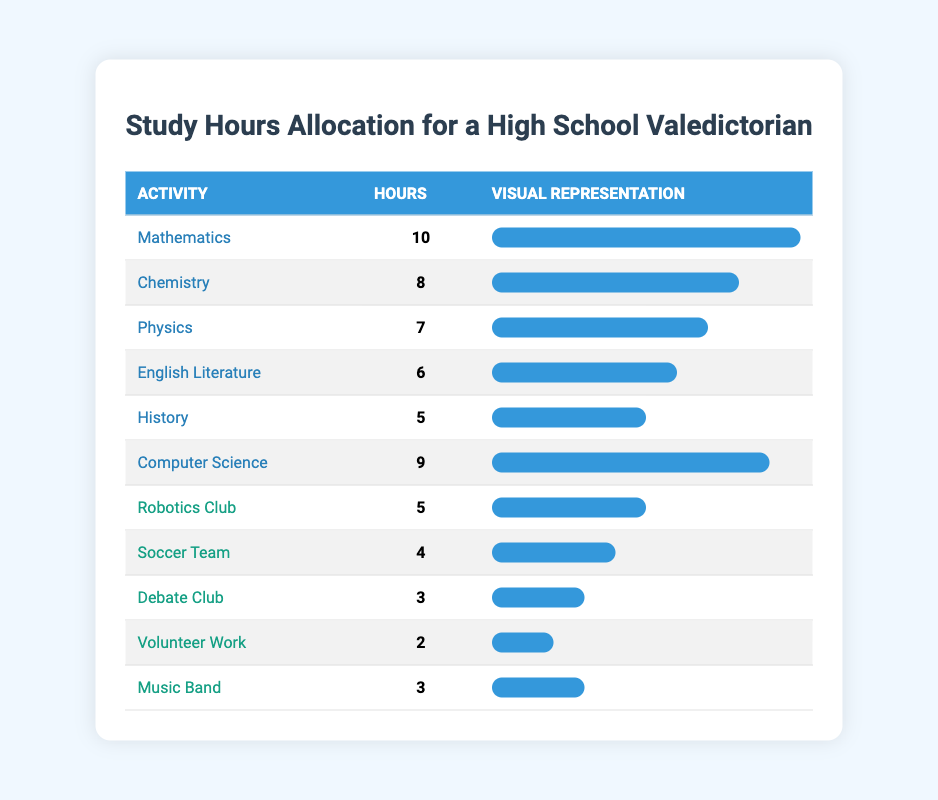What subject receives the most study hours? By examining the table, we can see that Mathematics has the highest number of study hours allocated, which is 10 hours.
Answer: Mathematics How many hours are dedicated to Chemistry? The table explicitly states that Chemistry has 8 hours allocated for study.
Answer: 8 Which extracurricular activity takes up the least amount of time? Looking at the extracurricular activities listed, Volunteer Work has the lowest allocation of study hours at 2 hours.
Answer: Volunteer Work What is the total number of study hours allocated for all subjects? To find the total for subjects, we sum the hours: 10 (Mathematics) + 8 (Chemistry) + 7 (Physics) + 6 (English Literature) + 5 (History) + 9 (Computer Science) = 45 hours total.
Answer: 45 How many more hours are allocated to Mathematics compared to History? The hours for Mathematics are 10 and for History are 5. Thus, the difference is 10 - 5 = 5 hours more for Mathematics.
Answer: 5 Are there more study hours allocated to extracurricular activities than to History? The total for extracurricular activities is 5 (Robotics Club) + 4 (Soccer Team) + 3 (Debate Club) + 2 (Volunteer Work) + 3 (Music Band) = 17, which is more than 5 hours allocated to History. Therefore, the answer is yes.
Answer: Yes What is the average study hours allocated across all subjects? The number of subjects is 6. The total study hours for subjects is 45. Therefore, the average is 45 hours / 6 subjects = 7.5 hours.
Answer: 7.5 If we combine the hours for the Robotics Club and Debate Club, how does it compare to the study hours for Physics? The hours for Robotics Club are 5 and for Debate Club are 3, summing these gives us 5 + 3 = 8, which is more than the 7 hours for Physics. Hence, Robotics and Debate together exceed the Physics study hours.
Answer: Yes What subject has the second highest study hours allocation? After Mathematics (10 hours), Computer Science has the second highest allocation with 9 hours, followed by Chemistry with 8 hours. So, the subject with the second highest is Computer Science.
Answer: Computer Science 